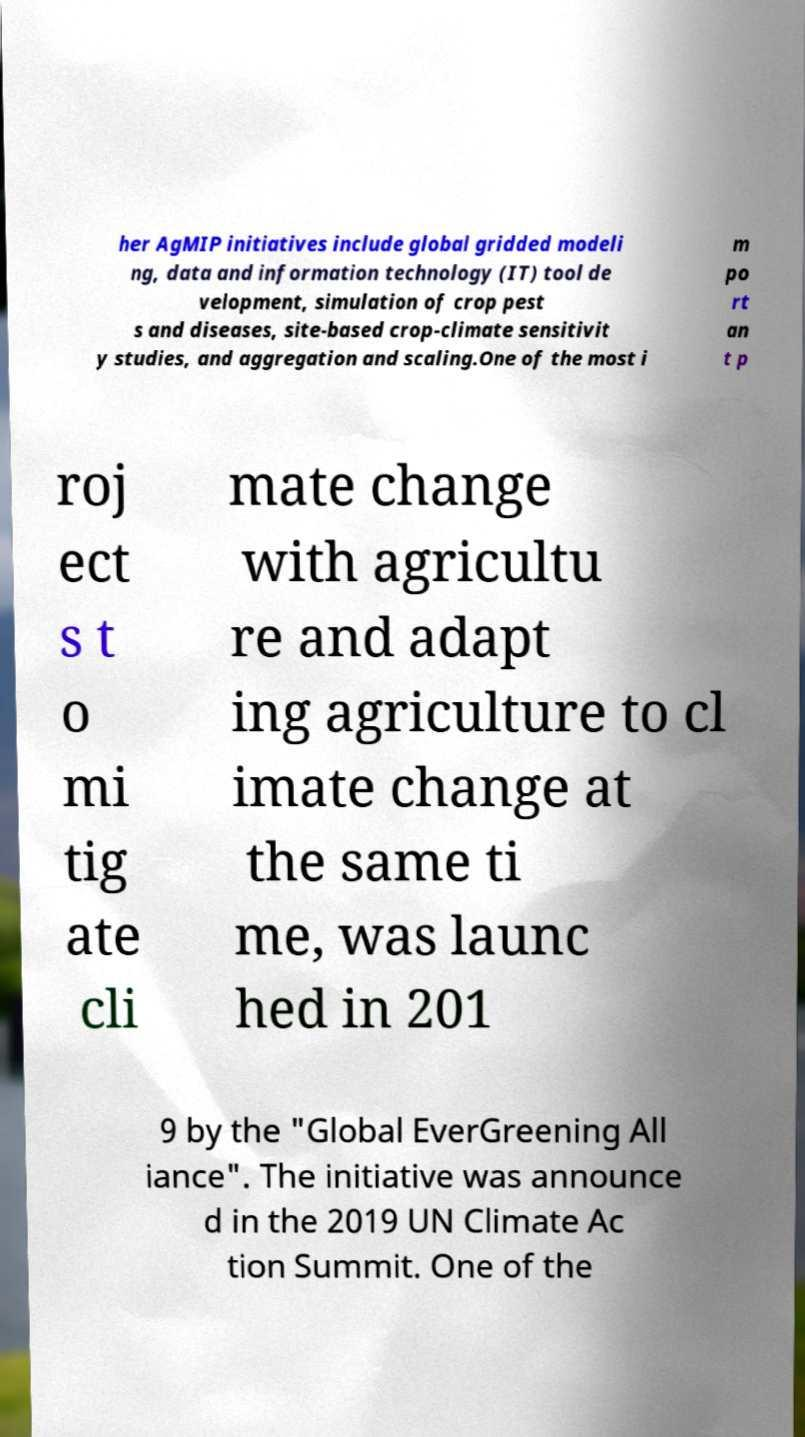I need the written content from this picture converted into text. Can you do that? her AgMIP initiatives include global gridded modeli ng, data and information technology (IT) tool de velopment, simulation of crop pest s and diseases, site-based crop-climate sensitivit y studies, and aggregation and scaling.One of the most i m po rt an t p roj ect s t o mi tig ate cli mate change with agricultu re and adapt ing agriculture to cl imate change at the same ti me, was launc hed in 201 9 by the "Global EverGreening All iance". The initiative was announce d in the 2019 UN Climate Ac tion Summit. One of the 